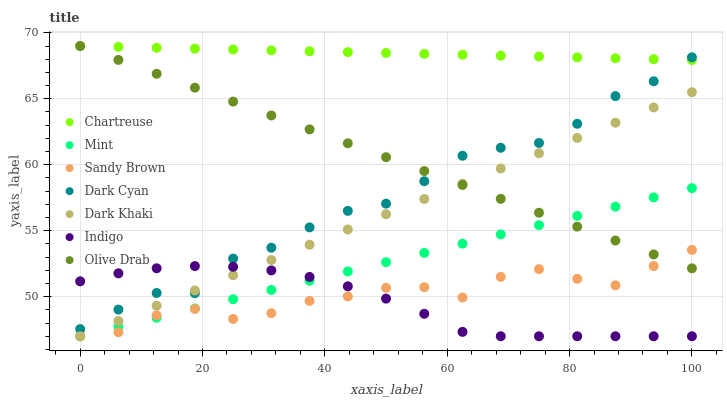Does Indigo have the minimum area under the curve?
Answer yes or no. Yes. Does Chartreuse have the maximum area under the curve?
Answer yes or no. Yes. Does Mint have the minimum area under the curve?
Answer yes or no. No. Does Mint have the maximum area under the curve?
Answer yes or no. No. Is Olive Drab the smoothest?
Answer yes or no. Yes. Is Sandy Brown the roughest?
Answer yes or no. Yes. Is Mint the smoothest?
Answer yes or no. No. Is Mint the roughest?
Answer yes or no. No. Does Indigo have the lowest value?
Answer yes or no. Yes. Does Chartreuse have the lowest value?
Answer yes or no. No. Does Olive Drab have the highest value?
Answer yes or no. Yes. Does Mint have the highest value?
Answer yes or no. No. Is Dark Khaki less than Chartreuse?
Answer yes or no. Yes. Is Dark Cyan greater than Sandy Brown?
Answer yes or no. Yes. Does Dark Khaki intersect Mint?
Answer yes or no. Yes. Is Dark Khaki less than Mint?
Answer yes or no. No. Is Dark Khaki greater than Mint?
Answer yes or no. No. Does Dark Khaki intersect Chartreuse?
Answer yes or no. No. 